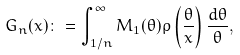<formula> <loc_0><loc_0><loc_500><loc_500>G _ { n } ( x ) \colon = \int _ { 1 / n } ^ { \infty } M _ { 1 } ( \theta ) \rho \left ( \frac { \theta } { x } \right ) \frac { d \theta } { \theta } ,</formula> 